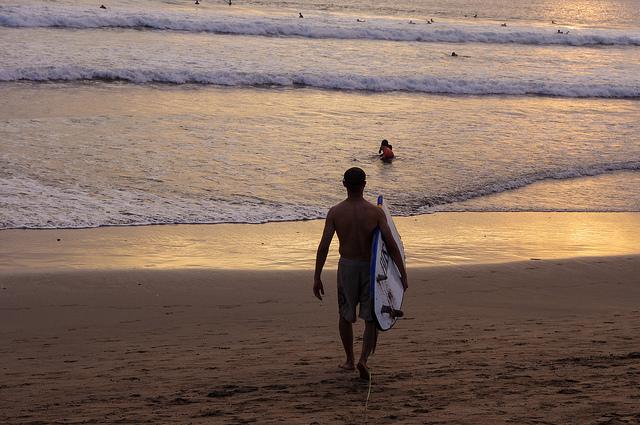Is the person walking away from the water?
Be succinct. No. Is there anyone in the water?
Short answer required. Yes. Are there multiple  people in the water?
Write a very short answer. Yes. 